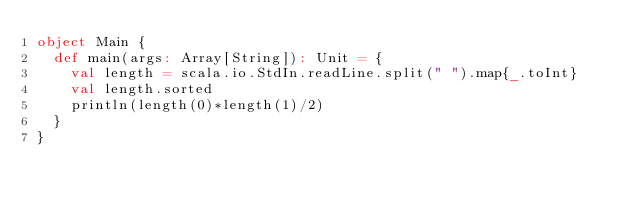<code> <loc_0><loc_0><loc_500><loc_500><_Scala_>object Main {
  def main(args: Array[String]): Unit = {
    val length = scala.io.StdIn.readLine.split(" ").map{_.toInt}
    val length.sorted
    println(length(0)*length(1)/2)
  }
}</code> 